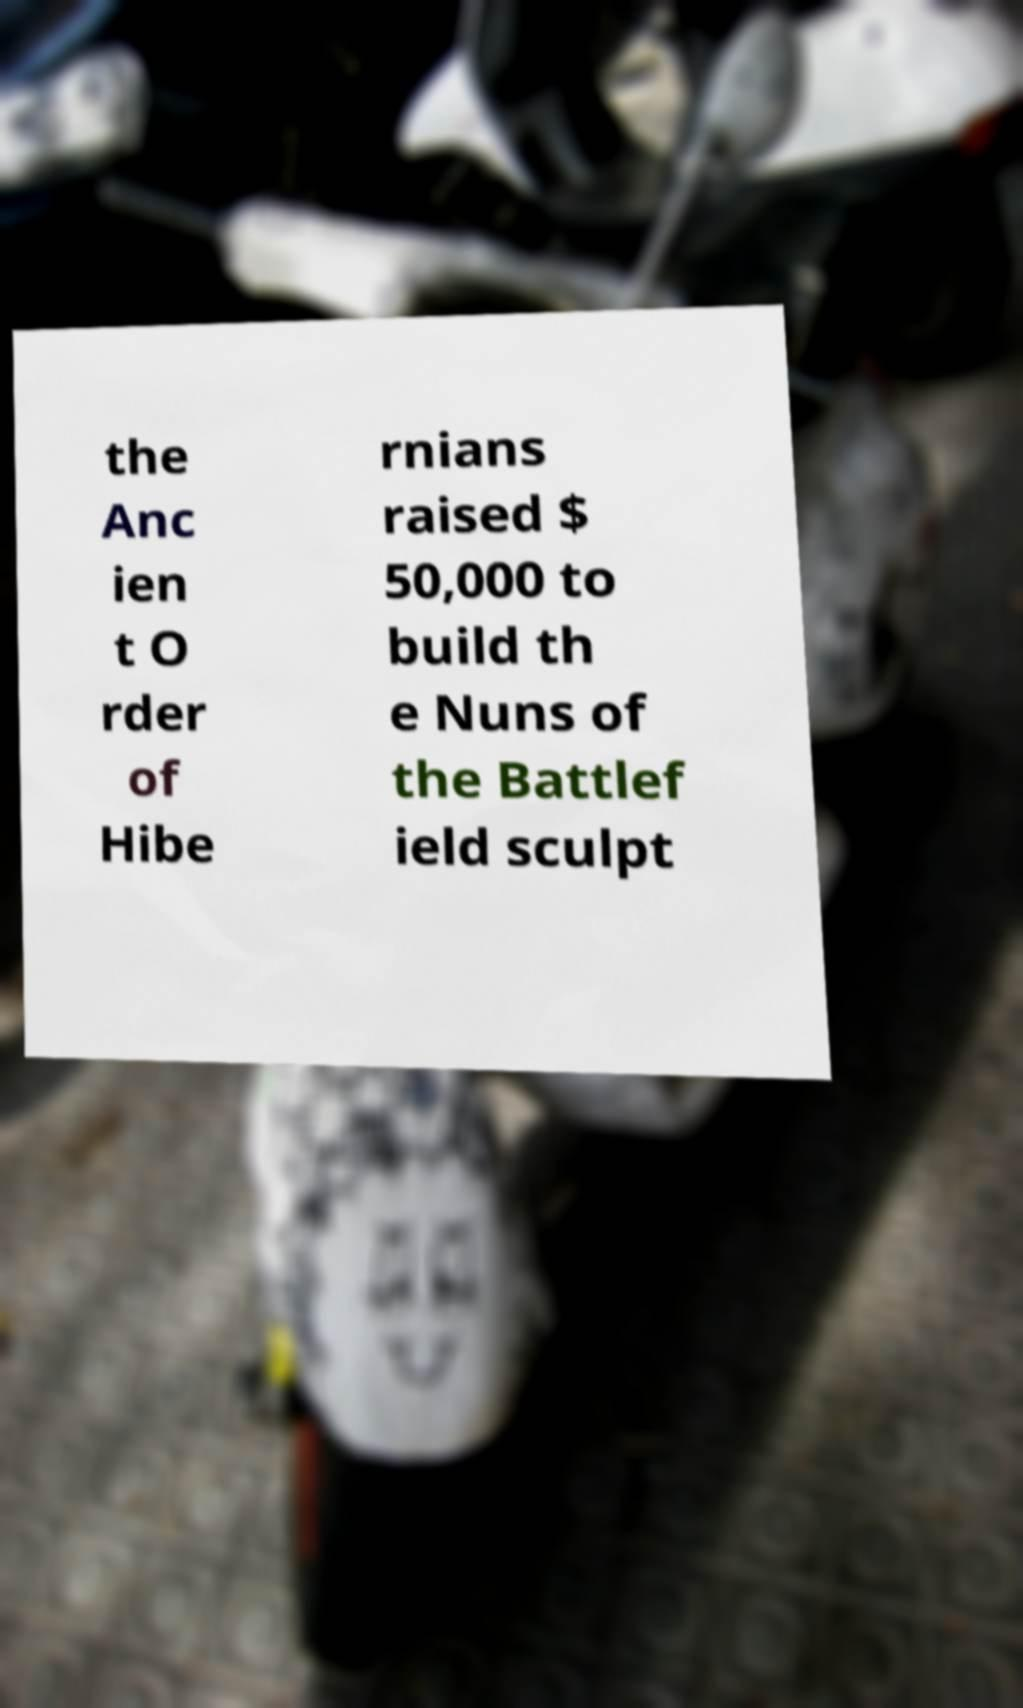What messages or text are displayed in this image? I need them in a readable, typed format. the Anc ien t O rder of Hibe rnians raised $ 50,000 to build th e Nuns of the Battlef ield sculpt 